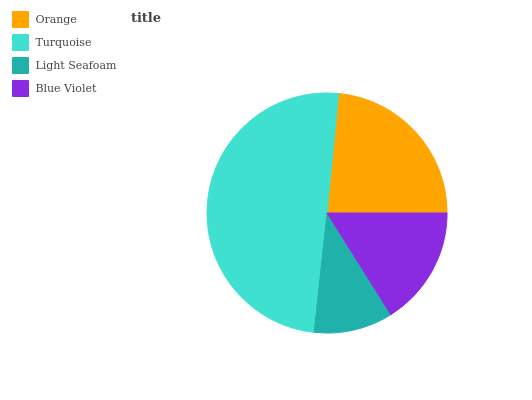Is Light Seafoam the minimum?
Answer yes or no. Yes. Is Turquoise the maximum?
Answer yes or no. Yes. Is Turquoise the minimum?
Answer yes or no. No. Is Light Seafoam the maximum?
Answer yes or no. No. Is Turquoise greater than Light Seafoam?
Answer yes or no. Yes. Is Light Seafoam less than Turquoise?
Answer yes or no. Yes. Is Light Seafoam greater than Turquoise?
Answer yes or no. No. Is Turquoise less than Light Seafoam?
Answer yes or no. No. Is Orange the high median?
Answer yes or no. Yes. Is Blue Violet the low median?
Answer yes or no. Yes. Is Light Seafoam the high median?
Answer yes or no. No. Is Orange the low median?
Answer yes or no. No. 